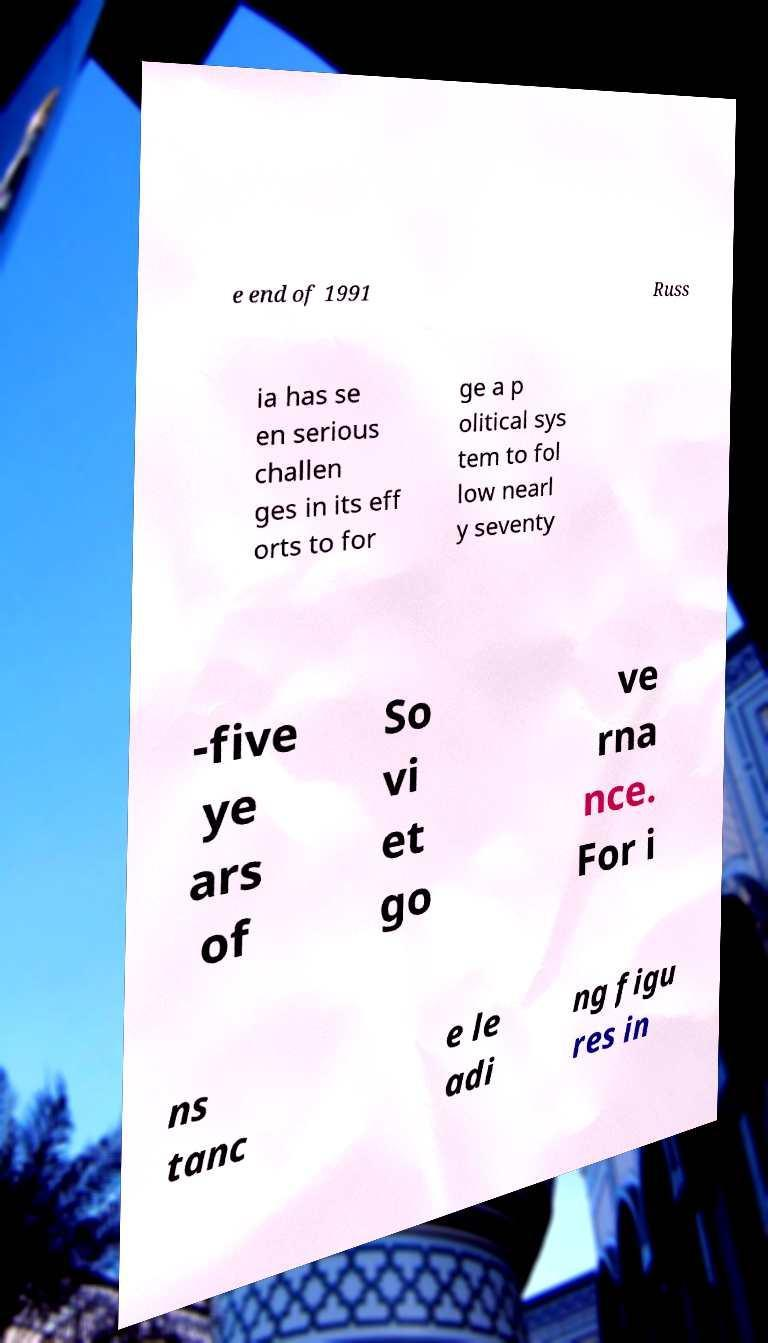There's text embedded in this image that I need extracted. Can you transcribe it verbatim? e end of 1991 Russ ia has se en serious challen ges in its eff orts to for ge a p olitical sys tem to fol low nearl y seventy -five ye ars of So vi et go ve rna nce. For i ns tanc e le adi ng figu res in 